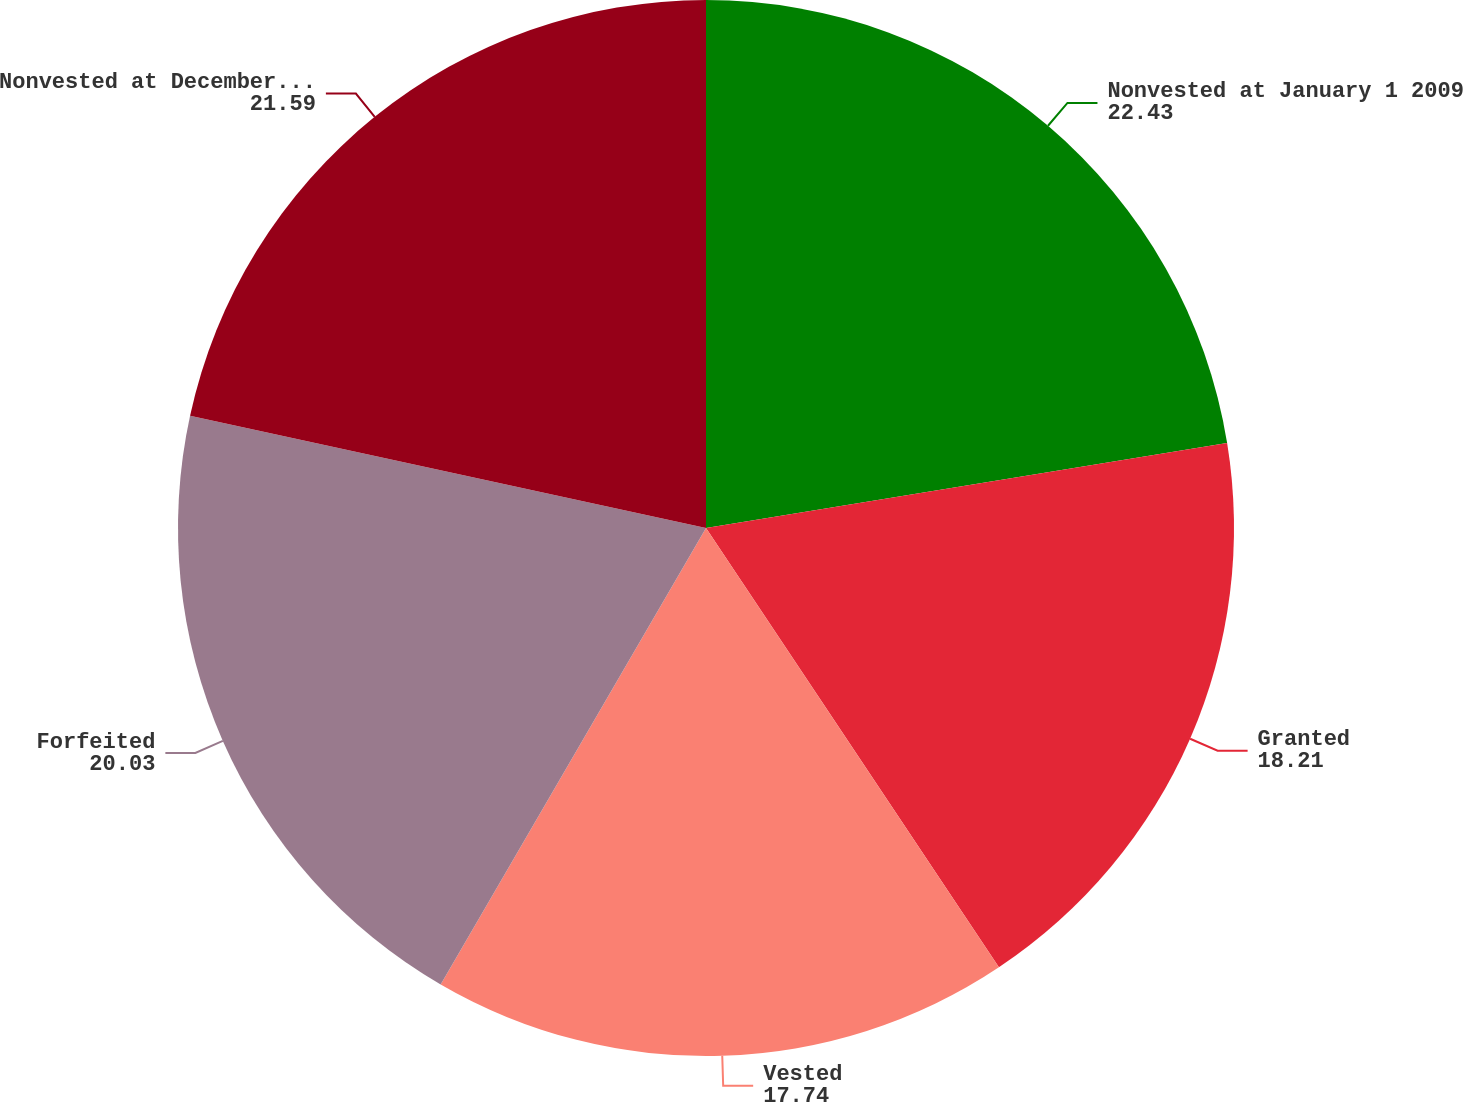Convert chart to OTSL. <chart><loc_0><loc_0><loc_500><loc_500><pie_chart><fcel>Nonvested at January 1 2009<fcel>Granted<fcel>Vested<fcel>Forfeited<fcel>Nonvested at December 31 2009<nl><fcel>22.43%<fcel>18.21%<fcel>17.74%<fcel>20.03%<fcel>21.59%<nl></chart> 